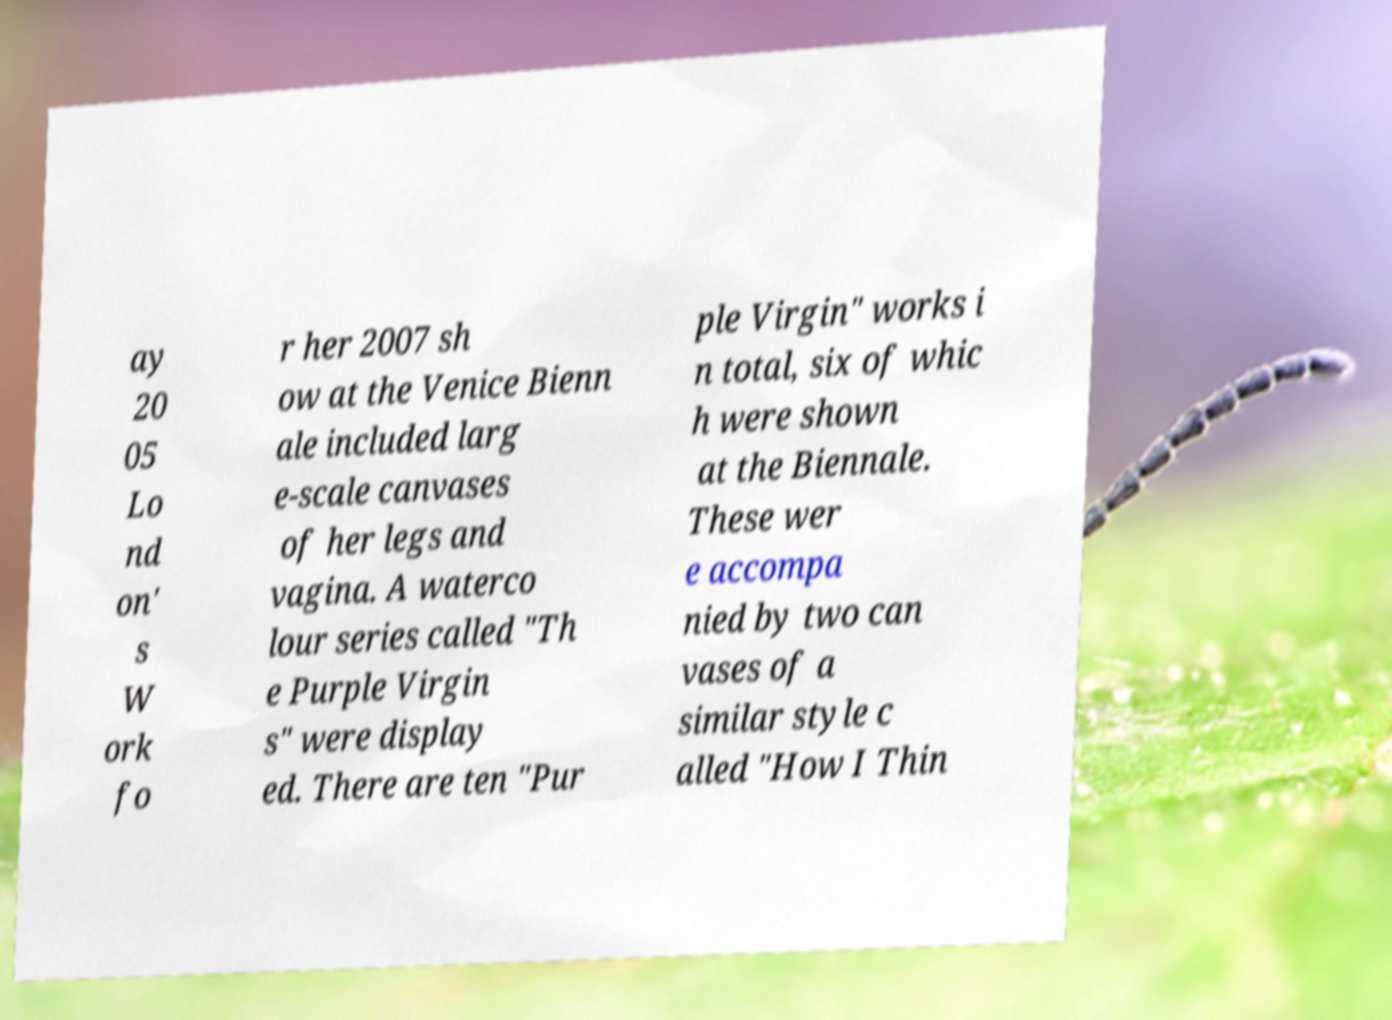Please read and relay the text visible in this image. What does it say? ay 20 05 Lo nd on' s W ork fo r her 2007 sh ow at the Venice Bienn ale included larg e-scale canvases of her legs and vagina. A waterco lour series called "Th e Purple Virgin s" were display ed. There are ten "Pur ple Virgin" works i n total, six of whic h were shown at the Biennale. These wer e accompa nied by two can vases of a similar style c alled "How I Thin 